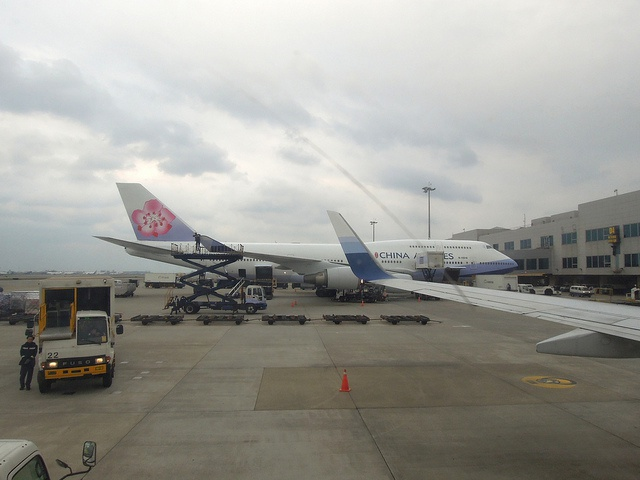Describe the objects in this image and their specific colors. I can see airplane in white, darkgray, gray, black, and lightgray tones, airplane in white, darkgray, gray, and black tones, truck in white, black, gray, and maroon tones, truck in white, gray, black, darkgray, and darkgreen tones, and truck in white, black, and gray tones in this image. 